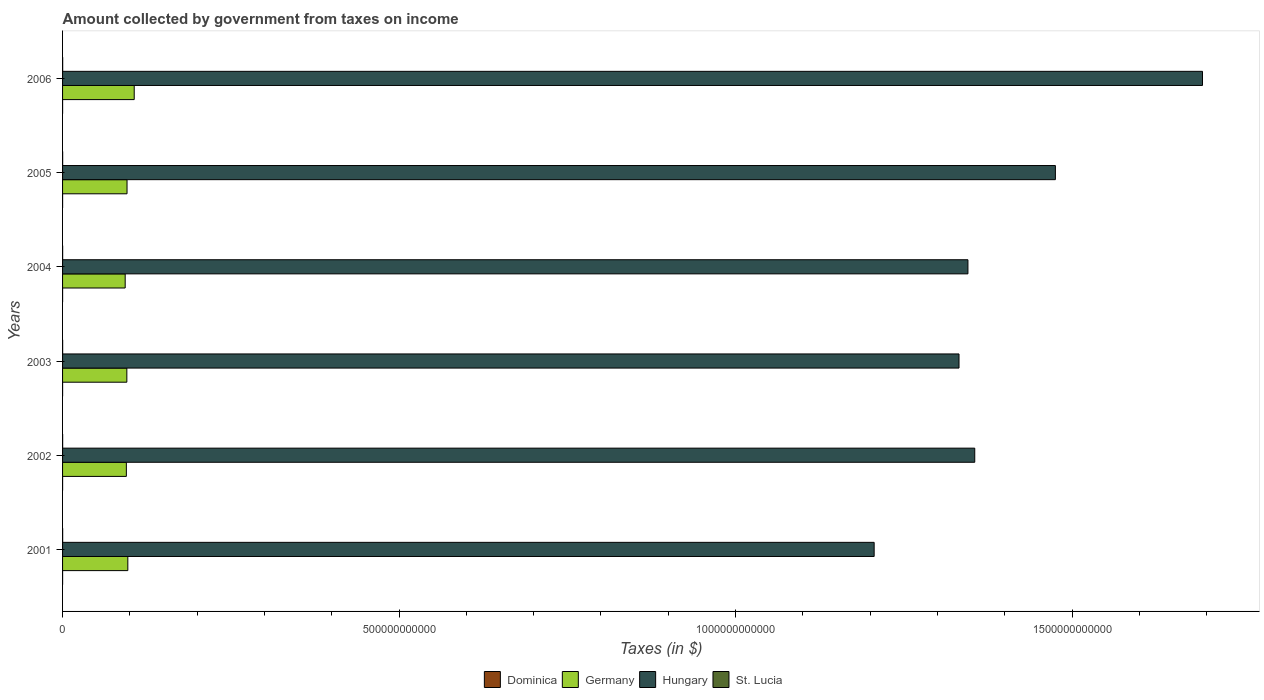How many different coloured bars are there?
Offer a very short reply. 4. How many groups of bars are there?
Offer a terse response. 6. Are the number of bars per tick equal to the number of legend labels?
Keep it short and to the point. Yes. What is the amount collected by government from taxes on income in Dominica in 2006?
Keep it short and to the point. 5.05e+07. Across all years, what is the maximum amount collected by government from taxes on income in Hungary?
Ensure brevity in your answer.  1.69e+12. Across all years, what is the minimum amount collected by government from taxes on income in Germany?
Offer a very short reply. 9.30e+1. In which year was the amount collected by government from taxes on income in Germany maximum?
Offer a terse response. 2006. What is the total amount collected by government from taxes on income in Dominica in the graph?
Keep it short and to the point. 2.72e+08. What is the difference between the amount collected by government from taxes on income in Germany in 2002 and that in 2004?
Provide a succinct answer. 1.74e+09. What is the difference between the amount collected by government from taxes on income in Germany in 2004 and the amount collected by government from taxes on income in St. Lucia in 2001?
Keep it short and to the point. 9.29e+1. What is the average amount collected by government from taxes on income in Dominica per year?
Your response must be concise. 4.53e+07. In the year 2005, what is the difference between the amount collected by government from taxes on income in Germany and amount collected by government from taxes on income in Hungary?
Offer a terse response. -1.38e+12. What is the ratio of the amount collected by government from taxes on income in Germany in 2005 to that in 2006?
Provide a succinct answer. 0.9. What is the difference between the highest and the second highest amount collected by government from taxes on income in Hungary?
Keep it short and to the point. 2.19e+11. What is the difference between the highest and the lowest amount collected by government from taxes on income in Hungary?
Your answer should be very brief. 4.88e+11. Is it the case that in every year, the sum of the amount collected by government from taxes on income in St. Lucia and amount collected by government from taxes on income in Germany is greater than the sum of amount collected by government from taxes on income in Dominica and amount collected by government from taxes on income in Hungary?
Keep it short and to the point. No. What does the 2nd bar from the top in 2004 represents?
Keep it short and to the point. Hungary. What does the 3rd bar from the bottom in 2003 represents?
Give a very brief answer. Hungary. How many bars are there?
Ensure brevity in your answer.  24. Are all the bars in the graph horizontal?
Your answer should be very brief. Yes. How many years are there in the graph?
Offer a terse response. 6. What is the difference between two consecutive major ticks on the X-axis?
Your answer should be very brief. 5.00e+11. Does the graph contain any zero values?
Provide a succinct answer. No. Where does the legend appear in the graph?
Your answer should be compact. Bottom center. How are the legend labels stacked?
Make the answer very short. Horizontal. What is the title of the graph?
Your response must be concise. Amount collected by government from taxes on income. What is the label or title of the X-axis?
Offer a terse response. Taxes (in $). What is the Taxes (in $) of Dominica in 2001?
Make the answer very short. 4.45e+07. What is the Taxes (in $) in Germany in 2001?
Your answer should be compact. 9.70e+1. What is the Taxes (in $) in Hungary in 2001?
Keep it short and to the point. 1.21e+12. What is the Taxes (in $) in St. Lucia in 2001?
Offer a terse response. 1.34e+08. What is the Taxes (in $) of Dominica in 2002?
Your response must be concise. 4.16e+07. What is the Taxes (in $) in Germany in 2002?
Your answer should be compact. 9.48e+1. What is the Taxes (in $) in Hungary in 2002?
Keep it short and to the point. 1.36e+12. What is the Taxes (in $) in St. Lucia in 2002?
Your answer should be very brief. 1.08e+08. What is the Taxes (in $) of Dominica in 2003?
Your answer should be compact. 4.52e+07. What is the Taxes (in $) in Germany in 2003?
Provide a short and direct response. 9.55e+1. What is the Taxes (in $) of Hungary in 2003?
Offer a terse response. 1.33e+12. What is the Taxes (in $) in St. Lucia in 2003?
Your response must be concise. 1.10e+08. What is the Taxes (in $) in Dominica in 2004?
Your answer should be very brief. 3.92e+07. What is the Taxes (in $) in Germany in 2004?
Offer a terse response. 9.30e+1. What is the Taxes (in $) of Hungary in 2004?
Offer a very short reply. 1.35e+12. What is the Taxes (in $) of St. Lucia in 2004?
Provide a succinct answer. 1.16e+08. What is the Taxes (in $) of Dominica in 2005?
Give a very brief answer. 5.07e+07. What is the Taxes (in $) of Germany in 2005?
Keep it short and to the point. 9.58e+1. What is the Taxes (in $) in Hungary in 2005?
Provide a succinct answer. 1.48e+12. What is the Taxes (in $) in St. Lucia in 2005?
Provide a succinct answer. 1.40e+08. What is the Taxes (in $) of Dominica in 2006?
Your answer should be compact. 5.05e+07. What is the Taxes (in $) of Germany in 2006?
Ensure brevity in your answer.  1.06e+11. What is the Taxes (in $) of Hungary in 2006?
Provide a succinct answer. 1.69e+12. What is the Taxes (in $) of St. Lucia in 2006?
Give a very brief answer. 1.48e+08. Across all years, what is the maximum Taxes (in $) of Dominica?
Ensure brevity in your answer.  5.07e+07. Across all years, what is the maximum Taxes (in $) in Germany?
Your response must be concise. 1.06e+11. Across all years, what is the maximum Taxes (in $) of Hungary?
Your answer should be very brief. 1.69e+12. Across all years, what is the maximum Taxes (in $) in St. Lucia?
Keep it short and to the point. 1.48e+08. Across all years, what is the minimum Taxes (in $) in Dominica?
Make the answer very short. 3.92e+07. Across all years, what is the minimum Taxes (in $) of Germany?
Keep it short and to the point. 9.30e+1. Across all years, what is the minimum Taxes (in $) of Hungary?
Keep it short and to the point. 1.21e+12. Across all years, what is the minimum Taxes (in $) of St. Lucia?
Provide a succinct answer. 1.08e+08. What is the total Taxes (in $) of Dominica in the graph?
Provide a short and direct response. 2.72e+08. What is the total Taxes (in $) in Germany in the graph?
Offer a terse response. 5.83e+11. What is the total Taxes (in $) of Hungary in the graph?
Provide a succinct answer. 8.41e+12. What is the total Taxes (in $) of St. Lucia in the graph?
Make the answer very short. 7.55e+08. What is the difference between the Taxes (in $) in Dominica in 2001 and that in 2002?
Provide a short and direct response. 2.90e+06. What is the difference between the Taxes (in $) of Germany in 2001 and that in 2002?
Keep it short and to the point. 2.18e+09. What is the difference between the Taxes (in $) of Hungary in 2001 and that in 2002?
Provide a short and direct response. -1.49e+11. What is the difference between the Taxes (in $) of St. Lucia in 2001 and that in 2002?
Provide a succinct answer. 2.61e+07. What is the difference between the Taxes (in $) in Dominica in 2001 and that in 2003?
Keep it short and to the point. -7.00e+05. What is the difference between the Taxes (in $) of Germany in 2001 and that in 2003?
Make the answer very short. 1.47e+09. What is the difference between the Taxes (in $) of Hungary in 2001 and that in 2003?
Offer a very short reply. -1.26e+11. What is the difference between the Taxes (in $) in St. Lucia in 2001 and that in 2003?
Offer a terse response. 2.40e+07. What is the difference between the Taxes (in $) in Dominica in 2001 and that in 2004?
Your answer should be very brief. 5.30e+06. What is the difference between the Taxes (in $) of Germany in 2001 and that in 2004?
Provide a succinct answer. 3.92e+09. What is the difference between the Taxes (in $) of Hungary in 2001 and that in 2004?
Your answer should be very brief. -1.39e+11. What is the difference between the Taxes (in $) of St. Lucia in 2001 and that in 2004?
Provide a succinct answer. 1.73e+07. What is the difference between the Taxes (in $) of Dominica in 2001 and that in 2005?
Give a very brief answer. -6.20e+06. What is the difference between the Taxes (in $) in Germany in 2001 and that in 2005?
Your answer should be very brief. 1.17e+09. What is the difference between the Taxes (in $) in Hungary in 2001 and that in 2005?
Provide a short and direct response. -2.69e+11. What is the difference between the Taxes (in $) in St. Lucia in 2001 and that in 2005?
Your response must be concise. -5.90e+06. What is the difference between the Taxes (in $) of Dominica in 2001 and that in 2006?
Give a very brief answer. -6.00e+06. What is the difference between the Taxes (in $) in Germany in 2001 and that in 2006?
Your response must be concise. -9.50e+09. What is the difference between the Taxes (in $) in Hungary in 2001 and that in 2006?
Give a very brief answer. -4.88e+11. What is the difference between the Taxes (in $) of St. Lucia in 2001 and that in 2006?
Your answer should be very brief. -1.47e+07. What is the difference between the Taxes (in $) of Dominica in 2002 and that in 2003?
Keep it short and to the point. -3.60e+06. What is the difference between the Taxes (in $) of Germany in 2002 and that in 2003?
Keep it short and to the point. -7.10e+08. What is the difference between the Taxes (in $) of Hungary in 2002 and that in 2003?
Provide a succinct answer. 2.34e+1. What is the difference between the Taxes (in $) in St. Lucia in 2002 and that in 2003?
Make the answer very short. -2.10e+06. What is the difference between the Taxes (in $) of Dominica in 2002 and that in 2004?
Offer a very short reply. 2.40e+06. What is the difference between the Taxes (in $) of Germany in 2002 and that in 2004?
Keep it short and to the point. 1.74e+09. What is the difference between the Taxes (in $) of Hungary in 2002 and that in 2004?
Offer a very short reply. 1.01e+1. What is the difference between the Taxes (in $) in St. Lucia in 2002 and that in 2004?
Offer a very short reply. -8.80e+06. What is the difference between the Taxes (in $) of Dominica in 2002 and that in 2005?
Ensure brevity in your answer.  -9.10e+06. What is the difference between the Taxes (in $) in Germany in 2002 and that in 2005?
Your answer should be very brief. -1.01e+09. What is the difference between the Taxes (in $) in Hungary in 2002 and that in 2005?
Keep it short and to the point. -1.20e+11. What is the difference between the Taxes (in $) in St. Lucia in 2002 and that in 2005?
Offer a very short reply. -3.20e+07. What is the difference between the Taxes (in $) in Dominica in 2002 and that in 2006?
Provide a succinct answer. -8.90e+06. What is the difference between the Taxes (in $) in Germany in 2002 and that in 2006?
Offer a very short reply. -1.17e+1. What is the difference between the Taxes (in $) of Hungary in 2002 and that in 2006?
Ensure brevity in your answer.  -3.38e+11. What is the difference between the Taxes (in $) of St. Lucia in 2002 and that in 2006?
Make the answer very short. -4.08e+07. What is the difference between the Taxes (in $) of Dominica in 2003 and that in 2004?
Give a very brief answer. 6.00e+06. What is the difference between the Taxes (in $) in Germany in 2003 and that in 2004?
Your answer should be very brief. 2.45e+09. What is the difference between the Taxes (in $) of Hungary in 2003 and that in 2004?
Provide a succinct answer. -1.33e+1. What is the difference between the Taxes (in $) in St. Lucia in 2003 and that in 2004?
Provide a short and direct response. -6.70e+06. What is the difference between the Taxes (in $) in Dominica in 2003 and that in 2005?
Provide a succinct answer. -5.50e+06. What is the difference between the Taxes (in $) in Germany in 2003 and that in 2005?
Your answer should be compact. -3.00e+08. What is the difference between the Taxes (in $) in Hungary in 2003 and that in 2005?
Offer a terse response. -1.43e+11. What is the difference between the Taxes (in $) of St. Lucia in 2003 and that in 2005?
Your response must be concise. -2.99e+07. What is the difference between the Taxes (in $) of Dominica in 2003 and that in 2006?
Give a very brief answer. -5.30e+06. What is the difference between the Taxes (in $) in Germany in 2003 and that in 2006?
Give a very brief answer. -1.10e+1. What is the difference between the Taxes (in $) of Hungary in 2003 and that in 2006?
Offer a terse response. -3.62e+11. What is the difference between the Taxes (in $) of St. Lucia in 2003 and that in 2006?
Offer a very short reply. -3.87e+07. What is the difference between the Taxes (in $) of Dominica in 2004 and that in 2005?
Offer a terse response. -1.15e+07. What is the difference between the Taxes (in $) in Germany in 2004 and that in 2005?
Make the answer very short. -2.75e+09. What is the difference between the Taxes (in $) of Hungary in 2004 and that in 2005?
Keep it short and to the point. -1.30e+11. What is the difference between the Taxes (in $) in St. Lucia in 2004 and that in 2005?
Your answer should be compact. -2.32e+07. What is the difference between the Taxes (in $) of Dominica in 2004 and that in 2006?
Offer a very short reply. -1.13e+07. What is the difference between the Taxes (in $) of Germany in 2004 and that in 2006?
Offer a terse response. -1.34e+1. What is the difference between the Taxes (in $) of Hungary in 2004 and that in 2006?
Provide a succinct answer. -3.49e+11. What is the difference between the Taxes (in $) in St. Lucia in 2004 and that in 2006?
Give a very brief answer. -3.20e+07. What is the difference between the Taxes (in $) of Dominica in 2005 and that in 2006?
Keep it short and to the point. 2.00e+05. What is the difference between the Taxes (in $) of Germany in 2005 and that in 2006?
Make the answer very short. -1.07e+1. What is the difference between the Taxes (in $) of Hungary in 2005 and that in 2006?
Keep it short and to the point. -2.19e+11. What is the difference between the Taxes (in $) in St. Lucia in 2005 and that in 2006?
Offer a very short reply. -8.80e+06. What is the difference between the Taxes (in $) in Dominica in 2001 and the Taxes (in $) in Germany in 2002?
Provide a succinct answer. -9.47e+1. What is the difference between the Taxes (in $) of Dominica in 2001 and the Taxes (in $) of Hungary in 2002?
Your answer should be very brief. -1.36e+12. What is the difference between the Taxes (in $) in Dominica in 2001 and the Taxes (in $) in St. Lucia in 2002?
Offer a very short reply. -6.31e+07. What is the difference between the Taxes (in $) in Germany in 2001 and the Taxes (in $) in Hungary in 2002?
Make the answer very short. -1.26e+12. What is the difference between the Taxes (in $) in Germany in 2001 and the Taxes (in $) in St. Lucia in 2002?
Your response must be concise. 9.69e+1. What is the difference between the Taxes (in $) of Hungary in 2001 and the Taxes (in $) of St. Lucia in 2002?
Your response must be concise. 1.21e+12. What is the difference between the Taxes (in $) in Dominica in 2001 and the Taxes (in $) in Germany in 2003?
Your answer should be very brief. -9.55e+1. What is the difference between the Taxes (in $) of Dominica in 2001 and the Taxes (in $) of Hungary in 2003?
Your answer should be compact. -1.33e+12. What is the difference between the Taxes (in $) in Dominica in 2001 and the Taxes (in $) in St. Lucia in 2003?
Your answer should be very brief. -6.52e+07. What is the difference between the Taxes (in $) of Germany in 2001 and the Taxes (in $) of Hungary in 2003?
Ensure brevity in your answer.  -1.24e+12. What is the difference between the Taxes (in $) in Germany in 2001 and the Taxes (in $) in St. Lucia in 2003?
Your answer should be compact. 9.69e+1. What is the difference between the Taxes (in $) of Hungary in 2001 and the Taxes (in $) of St. Lucia in 2003?
Your answer should be very brief. 1.21e+12. What is the difference between the Taxes (in $) of Dominica in 2001 and the Taxes (in $) of Germany in 2004?
Provide a short and direct response. -9.30e+1. What is the difference between the Taxes (in $) in Dominica in 2001 and the Taxes (in $) in Hungary in 2004?
Offer a terse response. -1.35e+12. What is the difference between the Taxes (in $) in Dominica in 2001 and the Taxes (in $) in St. Lucia in 2004?
Provide a succinct answer. -7.19e+07. What is the difference between the Taxes (in $) in Germany in 2001 and the Taxes (in $) in Hungary in 2004?
Provide a short and direct response. -1.25e+12. What is the difference between the Taxes (in $) of Germany in 2001 and the Taxes (in $) of St. Lucia in 2004?
Keep it short and to the point. 9.69e+1. What is the difference between the Taxes (in $) of Hungary in 2001 and the Taxes (in $) of St. Lucia in 2004?
Make the answer very short. 1.21e+12. What is the difference between the Taxes (in $) of Dominica in 2001 and the Taxes (in $) of Germany in 2005?
Make the answer very short. -9.58e+1. What is the difference between the Taxes (in $) of Dominica in 2001 and the Taxes (in $) of Hungary in 2005?
Keep it short and to the point. -1.48e+12. What is the difference between the Taxes (in $) in Dominica in 2001 and the Taxes (in $) in St. Lucia in 2005?
Ensure brevity in your answer.  -9.51e+07. What is the difference between the Taxes (in $) of Germany in 2001 and the Taxes (in $) of Hungary in 2005?
Provide a short and direct response. -1.38e+12. What is the difference between the Taxes (in $) in Germany in 2001 and the Taxes (in $) in St. Lucia in 2005?
Offer a very short reply. 9.68e+1. What is the difference between the Taxes (in $) in Hungary in 2001 and the Taxes (in $) in St. Lucia in 2005?
Offer a very short reply. 1.21e+12. What is the difference between the Taxes (in $) of Dominica in 2001 and the Taxes (in $) of Germany in 2006?
Ensure brevity in your answer.  -1.06e+11. What is the difference between the Taxes (in $) of Dominica in 2001 and the Taxes (in $) of Hungary in 2006?
Your answer should be compact. -1.69e+12. What is the difference between the Taxes (in $) in Dominica in 2001 and the Taxes (in $) in St. Lucia in 2006?
Provide a short and direct response. -1.04e+08. What is the difference between the Taxes (in $) in Germany in 2001 and the Taxes (in $) in Hungary in 2006?
Make the answer very short. -1.60e+12. What is the difference between the Taxes (in $) of Germany in 2001 and the Taxes (in $) of St. Lucia in 2006?
Make the answer very short. 9.68e+1. What is the difference between the Taxes (in $) in Hungary in 2001 and the Taxes (in $) in St. Lucia in 2006?
Ensure brevity in your answer.  1.21e+12. What is the difference between the Taxes (in $) of Dominica in 2002 and the Taxes (in $) of Germany in 2003?
Your answer should be very brief. -9.55e+1. What is the difference between the Taxes (in $) in Dominica in 2002 and the Taxes (in $) in Hungary in 2003?
Your answer should be compact. -1.33e+12. What is the difference between the Taxes (in $) in Dominica in 2002 and the Taxes (in $) in St. Lucia in 2003?
Give a very brief answer. -6.81e+07. What is the difference between the Taxes (in $) in Germany in 2002 and the Taxes (in $) in Hungary in 2003?
Offer a terse response. -1.24e+12. What is the difference between the Taxes (in $) in Germany in 2002 and the Taxes (in $) in St. Lucia in 2003?
Ensure brevity in your answer.  9.47e+1. What is the difference between the Taxes (in $) of Hungary in 2002 and the Taxes (in $) of St. Lucia in 2003?
Ensure brevity in your answer.  1.36e+12. What is the difference between the Taxes (in $) of Dominica in 2002 and the Taxes (in $) of Germany in 2004?
Give a very brief answer. -9.30e+1. What is the difference between the Taxes (in $) of Dominica in 2002 and the Taxes (in $) of Hungary in 2004?
Offer a terse response. -1.35e+12. What is the difference between the Taxes (in $) in Dominica in 2002 and the Taxes (in $) in St. Lucia in 2004?
Offer a very short reply. -7.48e+07. What is the difference between the Taxes (in $) of Germany in 2002 and the Taxes (in $) of Hungary in 2004?
Ensure brevity in your answer.  -1.25e+12. What is the difference between the Taxes (in $) in Germany in 2002 and the Taxes (in $) in St. Lucia in 2004?
Offer a very short reply. 9.47e+1. What is the difference between the Taxes (in $) in Hungary in 2002 and the Taxes (in $) in St. Lucia in 2004?
Your response must be concise. 1.36e+12. What is the difference between the Taxes (in $) in Dominica in 2002 and the Taxes (in $) in Germany in 2005?
Provide a short and direct response. -9.58e+1. What is the difference between the Taxes (in $) of Dominica in 2002 and the Taxes (in $) of Hungary in 2005?
Offer a terse response. -1.48e+12. What is the difference between the Taxes (in $) in Dominica in 2002 and the Taxes (in $) in St. Lucia in 2005?
Your answer should be very brief. -9.80e+07. What is the difference between the Taxes (in $) in Germany in 2002 and the Taxes (in $) in Hungary in 2005?
Your answer should be compact. -1.38e+12. What is the difference between the Taxes (in $) in Germany in 2002 and the Taxes (in $) in St. Lucia in 2005?
Make the answer very short. 9.47e+1. What is the difference between the Taxes (in $) in Hungary in 2002 and the Taxes (in $) in St. Lucia in 2005?
Provide a short and direct response. 1.36e+12. What is the difference between the Taxes (in $) in Dominica in 2002 and the Taxes (in $) in Germany in 2006?
Offer a very short reply. -1.06e+11. What is the difference between the Taxes (in $) of Dominica in 2002 and the Taxes (in $) of Hungary in 2006?
Give a very brief answer. -1.69e+12. What is the difference between the Taxes (in $) of Dominica in 2002 and the Taxes (in $) of St. Lucia in 2006?
Provide a succinct answer. -1.07e+08. What is the difference between the Taxes (in $) in Germany in 2002 and the Taxes (in $) in Hungary in 2006?
Your answer should be compact. -1.60e+12. What is the difference between the Taxes (in $) of Germany in 2002 and the Taxes (in $) of St. Lucia in 2006?
Your response must be concise. 9.46e+1. What is the difference between the Taxes (in $) in Hungary in 2002 and the Taxes (in $) in St. Lucia in 2006?
Offer a very short reply. 1.36e+12. What is the difference between the Taxes (in $) of Dominica in 2003 and the Taxes (in $) of Germany in 2004?
Keep it short and to the point. -9.30e+1. What is the difference between the Taxes (in $) in Dominica in 2003 and the Taxes (in $) in Hungary in 2004?
Ensure brevity in your answer.  -1.35e+12. What is the difference between the Taxes (in $) in Dominica in 2003 and the Taxes (in $) in St. Lucia in 2004?
Your response must be concise. -7.12e+07. What is the difference between the Taxes (in $) of Germany in 2003 and the Taxes (in $) of Hungary in 2004?
Make the answer very short. -1.25e+12. What is the difference between the Taxes (in $) in Germany in 2003 and the Taxes (in $) in St. Lucia in 2004?
Your response must be concise. 9.54e+1. What is the difference between the Taxes (in $) in Hungary in 2003 and the Taxes (in $) in St. Lucia in 2004?
Ensure brevity in your answer.  1.33e+12. What is the difference between the Taxes (in $) of Dominica in 2003 and the Taxes (in $) of Germany in 2005?
Provide a succinct answer. -9.58e+1. What is the difference between the Taxes (in $) in Dominica in 2003 and the Taxes (in $) in Hungary in 2005?
Ensure brevity in your answer.  -1.48e+12. What is the difference between the Taxes (in $) of Dominica in 2003 and the Taxes (in $) of St. Lucia in 2005?
Give a very brief answer. -9.44e+07. What is the difference between the Taxes (in $) of Germany in 2003 and the Taxes (in $) of Hungary in 2005?
Your response must be concise. -1.38e+12. What is the difference between the Taxes (in $) of Germany in 2003 and the Taxes (in $) of St. Lucia in 2005?
Provide a short and direct response. 9.54e+1. What is the difference between the Taxes (in $) of Hungary in 2003 and the Taxes (in $) of St. Lucia in 2005?
Your response must be concise. 1.33e+12. What is the difference between the Taxes (in $) in Dominica in 2003 and the Taxes (in $) in Germany in 2006?
Keep it short and to the point. -1.06e+11. What is the difference between the Taxes (in $) in Dominica in 2003 and the Taxes (in $) in Hungary in 2006?
Your answer should be compact. -1.69e+12. What is the difference between the Taxes (in $) in Dominica in 2003 and the Taxes (in $) in St. Lucia in 2006?
Provide a succinct answer. -1.03e+08. What is the difference between the Taxes (in $) in Germany in 2003 and the Taxes (in $) in Hungary in 2006?
Offer a very short reply. -1.60e+12. What is the difference between the Taxes (in $) in Germany in 2003 and the Taxes (in $) in St. Lucia in 2006?
Ensure brevity in your answer.  9.54e+1. What is the difference between the Taxes (in $) in Hungary in 2003 and the Taxes (in $) in St. Lucia in 2006?
Provide a succinct answer. 1.33e+12. What is the difference between the Taxes (in $) of Dominica in 2004 and the Taxes (in $) of Germany in 2005?
Keep it short and to the point. -9.58e+1. What is the difference between the Taxes (in $) in Dominica in 2004 and the Taxes (in $) in Hungary in 2005?
Ensure brevity in your answer.  -1.48e+12. What is the difference between the Taxes (in $) in Dominica in 2004 and the Taxes (in $) in St. Lucia in 2005?
Make the answer very short. -1.00e+08. What is the difference between the Taxes (in $) of Germany in 2004 and the Taxes (in $) of Hungary in 2005?
Offer a terse response. -1.38e+12. What is the difference between the Taxes (in $) of Germany in 2004 and the Taxes (in $) of St. Lucia in 2005?
Your answer should be very brief. 9.29e+1. What is the difference between the Taxes (in $) of Hungary in 2004 and the Taxes (in $) of St. Lucia in 2005?
Provide a short and direct response. 1.35e+12. What is the difference between the Taxes (in $) of Dominica in 2004 and the Taxes (in $) of Germany in 2006?
Give a very brief answer. -1.06e+11. What is the difference between the Taxes (in $) of Dominica in 2004 and the Taxes (in $) of Hungary in 2006?
Offer a very short reply. -1.69e+12. What is the difference between the Taxes (in $) in Dominica in 2004 and the Taxes (in $) in St. Lucia in 2006?
Provide a succinct answer. -1.09e+08. What is the difference between the Taxes (in $) in Germany in 2004 and the Taxes (in $) in Hungary in 2006?
Provide a short and direct response. -1.60e+12. What is the difference between the Taxes (in $) of Germany in 2004 and the Taxes (in $) of St. Lucia in 2006?
Offer a very short reply. 9.29e+1. What is the difference between the Taxes (in $) of Hungary in 2004 and the Taxes (in $) of St. Lucia in 2006?
Offer a very short reply. 1.35e+12. What is the difference between the Taxes (in $) of Dominica in 2005 and the Taxes (in $) of Germany in 2006?
Provide a short and direct response. -1.06e+11. What is the difference between the Taxes (in $) of Dominica in 2005 and the Taxes (in $) of Hungary in 2006?
Your answer should be very brief. -1.69e+12. What is the difference between the Taxes (in $) in Dominica in 2005 and the Taxes (in $) in St. Lucia in 2006?
Make the answer very short. -9.77e+07. What is the difference between the Taxes (in $) in Germany in 2005 and the Taxes (in $) in Hungary in 2006?
Offer a terse response. -1.60e+12. What is the difference between the Taxes (in $) of Germany in 2005 and the Taxes (in $) of St. Lucia in 2006?
Your answer should be very brief. 9.57e+1. What is the difference between the Taxes (in $) of Hungary in 2005 and the Taxes (in $) of St. Lucia in 2006?
Provide a short and direct response. 1.48e+12. What is the average Taxes (in $) in Dominica per year?
Provide a short and direct response. 4.53e+07. What is the average Taxes (in $) of Germany per year?
Give a very brief answer. 9.71e+1. What is the average Taxes (in $) in Hungary per year?
Provide a succinct answer. 1.40e+12. What is the average Taxes (in $) of St. Lucia per year?
Keep it short and to the point. 1.26e+08. In the year 2001, what is the difference between the Taxes (in $) in Dominica and Taxes (in $) in Germany?
Your response must be concise. -9.69e+1. In the year 2001, what is the difference between the Taxes (in $) of Dominica and Taxes (in $) of Hungary?
Offer a terse response. -1.21e+12. In the year 2001, what is the difference between the Taxes (in $) in Dominica and Taxes (in $) in St. Lucia?
Offer a terse response. -8.92e+07. In the year 2001, what is the difference between the Taxes (in $) of Germany and Taxes (in $) of Hungary?
Provide a short and direct response. -1.11e+12. In the year 2001, what is the difference between the Taxes (in $) in Germany and Taxes (in $) in St. Lucia?
Make the answer very short. 9.68e+1. In the year 2001, what is the difference between the Taxes (in $) in Hungary and Taxes (in $) in St. Lucia?
Provide a short and direct response. 1.21e+12. In the year 2002, what is the difference between the Taxes (in $) in Dominica and Taxes (in $) in Germany?
Provide a short and direct response. -9.47e+1. In the year 2002, what is the difference between the Taxes (in $) in Dominica and Taxes (in $) in Hungary?
Ensure brevity in your answer.  -1.36e+12. In the year 2002, what is the difference between the Taxes (in $) in Dominica and Taxes (in $) in St. Lucia?
Give a very brief answer. -6.60e+07. In the year 2002, what is the difference between the Taxes (in $) in Germany and Taxes (in $) in Hungary?
Provide a short and direct response. -1.26e+12. In the year 2002, what is the difference between the Taxes (in $) of Germany and Taxes (in $) of St. Lucia?
Your answer should be very brief. 9.47e+1. In the year 2002, what is the difference between the Taxes (in $) in Hungary and Taxes (in $) in St. Lucia?
Give a very brief answer. 1.36e+12. In the year 2003, what is the difference between the Taxes (in $) of Dominica and Taxes (in $) of Germany?
Your response must be concise. -9.55e+1. In the year 2003, what is the difference between the Taxes (in $) of Dominica and Taxes (in $) of Hungary?
Give a very brief answer. -1.33e+12. In the year 2003, what is the difference between the Taxes (in $) of Dominica and Taxes (in $) of St. Lucia?
Ensure brevity in your answer.  -6.45e+07. In the year 2003, what is the difference between the Taxes (in $) in Germany and Taxes (in $) in Hungary?
Provide a short and direct response. -1.24e+12. In the year 2003, what is the difference between the Taxes (in $) of Germany and Taxes (in $) of St. Lucia?
Offer a very short reply. 9.54e+1. In the year 2003, what is the difference between the Taxes (in $) of Hungary and Taxes (in $) of St. Lucia?
Provide a short and direct response. 1.33e+12. In the year 2004, what is the difference between the Taxes (in $) of Dominica and Taxes (in $) of Germany?
Keep it short and to the point. -9.30e+1. In the year 2004, what is the difference between the Taxes (in $) in Dominica and Taxes (in $) in Hungary?
Provide a short and direct response. -1.35e+12. In the year 2004, what is the difference between the Taxes (in $) of Dominica and Taxes (in $) of St. Lucia?
Provide a short and direct response. -7.72e+07. In the year 2004, what is the difference between the Taxes (in $) of Germany and Taxes (in $) of Hungary?
Keep it short and to the point. -1.25e+12. In the year 2004, what is the difference between the Taxes (in $) of Germany and Taxes (in $) of St. Lucia?
Offer a very short reply. 9.29e+1. In the year 2004, what is the difference between the Taxes (in $) in Hungary and Taxes (in $) in St. Lucia?
Provide a short and direct response. 1.35e+12. In the year 2005, what is the difference between the Taxes (in $) of Dominica and Taxes (in $) of Germany?
Ensure brevity in your answer.  -9.57e+1. In the year 2005, what is the difference between the Taxes (in $) in Dominica and Taxes (in $) in Hungary?
Offer a terse response. -1.48e+12. In the year 2005, what is the difference between the Taxes (in $) in Dominica and Taxes (in $) in St. Lucia?
Offer a very short reply. -8.89e+07. In the year 2005, what is the difference between the Taxes (in $) in Germany and Taxes (in $) in Hungary?
Ensure brevity in your answer.  -1.38e+12. In the year 2005, what is the difference between the Taxes (in $) of Germany and Taxes (in $) of St. Lucia?
Ensure brevity in your answer.  9.57e+1. In the year 2005, what is the difference between the Taxes (in $) of Hungary and Taxes (in $) of St. Lucia?
Provide a succinct answer. 1.48e+12. In the year 2006, what is the difference between the Taxes (in $) in Dominica and Taxes (in $) in Germany?
Your answer should be very brief. -1.06e+11. In the year 2006, what is the difference between the Taxes (in $) of Dominica and Taxes (in $) of Hungary?
Give a very brief answer. -1.69e+12. In the year 2006, what is the difference between the Taxes (in $) in Dominica and Taxes (in $) in St. Lucia?
Your answer should be very brief. -9.79e+07. In the year 2006, what is the difference between the Taxes (in $) in Germany and Taxes (in $) in Hungary?
Provide a succinct answer. -1.59e+12. In the year 2006, what is the difference between the Taxes (in $) of Germany and Taxes (in $) of St. Lucia?
Your answer should be very brief. 1.06e+11. In the year 2006, what is the difference between the Taxes (in $) of Hungary and Taxes (in $) of St. Lucia?
Give a very brief answer. 1.69e+12. What is the ratio of the Taxes (in $) of Dominica in 2001 to that in 2002?
Provide a short and direct response. 1.07. What is the ratio of the Taxes (in $) in Hungary in 2001 to that in 2002?
Your answer should be compact. 0.89. What is the ratio of the Taxes (in $) in St. Lucia in 2001 to that in 2002?
Your answer should be very brief. 1.24. What is the ratio of the Taxes (in $) of Dominica in 2001 to that in 2003?
Keep it short and to the point. 0.98. What is the ratio of the Taxes (in $) of Germany in 2001 to that in 2003?
Provide a succinct answer. 1.02. What is the ratio of the Taxes (in $) of Hungary in 2001 to that in 2003?
Provide a succinct answer. 0.91. What is the ratio of the Taxes (in $) in St. Lucia in 2001 to that in 2003?
Ensure brevity in your answer.  1.22. What is the ratio of the Taxes (in $) of Dominica in 2001 to that in 2004?
Your response must be concise. 1.14. What is the ratio of the Taxes (in $) of Germany in 2001 to that in 2004?
Your response must be concise. 1.04. What is the ratio of the Taxes (in $) in Hungary in 2001 to that in 2004?
Keep it short and to the point. 0.9. What is the ratio of the Taxes (in $) in St. Lucia in 2001 to that in 2004?
Offer a very short reply. 1.15. What is the ratio of the Taxes (in $) of Dominica in 2001 to that in 2005?
Offer a very short reply. 0.88. What is the ratio of the Taxes (in $) of Germany in 2001 to that in 2005?
Your answer should be very brief. 1.01. What is the ratio of the Taxes (in $) in Hungary in 2001 to that in 2005?
Give a very brief answer. 0.82. What is the ratio of the Taxes (in $) of St. Lucia in 2001 to that in 2005?
Give a very brief answer. 0.96. What is the ratio of the Taxes (in $) of Dominica in 2001 to that in 2006?
Your answer should be compact. 0.88. What is the ratio of the Taxes (in $) of Germany in 2001 to that in 2006?
Ensure brevity in your answer.  0.91. What is the ratio of the Taxes (in $) in Hungary in 2001 to that in 2006?
Make the answer very short. 0.71. What is the ratio of the Taxes (in $) in St. Lucia in 2001 to that in 2006?
Offer a terse response. 0.9. What is the ratio of the Taxes (in $) of Dominica in 2002 to that in 2003?
Your response must be concise. 0.92. What is the ratio of the Taxes (in $) of Germany in 2002 to that in 2003?
Your answer should be very brief. 0.99. What is the ratio of the Taxes (in $) of Hungary in 2002 to that in 2003?
Provide a short and direct response. 1.02. What is the ratio of the Taxes (in $) of St. Lucia in 2002 to that in 2003?
Offer a terse response. 0.98. What is the ratio of the Taxes (in $) of Dominica in 2002 to that in 2004?
Provide a succinct answer. 1.06. What is the ratio of the Taxes (in $) in Germany in 2002 to that in 2004?
Your answer should be compact. 1.02. What is the ratio of the Taxes (in $) in Hungary in 2002 to that in 2004?
Your response must be concise. 1.01. What is the ratio of the Taxes (in $) in St. Lucia in 2002 to that in 2004?
Make the answer very short. 0.92. What is the ratio of the Taxes (in $) of Dominica in 2002 to that in 2005?
Give a very brief answer. 0.82. What is the ratio of the Taxes (in $) of Hungary in 2002 to that in 2005?
Provide a succinct answer. 0.92. What is the ratio of the Taxes (in $) of St. Lucia in 2002 to that in 2005?
Your response must be concise. 0.77. What is the ratio of the Taxes (in $) in Dominica in 2002 to that in 2006?
Your answer should be compact. 0.82. What is the ratio of the Taxes (in $) in Germany in 2002 to that in 2006?
Make the answer very short. 0.89. What is the ratio of the Taxes (in $) in Hungary in 2002 to that in 2006?
Your answer should be very brief. 0.8. What is the ratio of the Taxes (in $) of St. Lucia in 2002 to that in 2006?
Provide a short and direct response. 0.73. What is the ratio of the Taxes (in $) of Dominica in 2003 to that in 2004?
Your response must be concise. 1.15. What is the ratio of the Taxes (in $) in Germany in 2003 to that in 2004?
Offer a terse response. 1.03. What is the ratio of the Taxes (in $) in St. Lucia in 2003 to that in 2004?
Provide a succinct answer. 0.94. What is the ratio of the Taxes (in $) of Dominica in 2003 to that in 2005?
Provide a succinct answer. 0.89. What is the ratio of the Taxes (in $) of Germany in 2003 to that in 2005?
Provide a succinct answer. 1. What is the ratio of the Taxes (in $) in Hungary in 2003 to that in 2005?
Provide a succinct answer. 0.9. What is the ratio of the Taxes (in $) of St. Lucia in 2003 to that in 2005?
Provide a succinct answer. 0.79. What is the ratio of the Taxes (in $) in Dominica in 2003 to that in 2006?
Provide a short and direct response. 0.9. What is the ratio of the Taxes (in $) in Germany in 2003 to that in 2006?
Give a very brief answer. 0.9. What is the ratio of the Taxes (in $) in Hungary in 2003 to that in 2006?
Your answer should be compact. 0.79. What is the ratio of the Taxes (in $) of St. Lucia in 2003 to that in 2006?
Give a very brief answer. 0.74. What is the ratio of the Taxes (in $) in Dominica in 2004 to that in 2005?
Make the answer very short. 0.77. What is the ratio of the Taxes (in $) in Germany in 2004 to that in 2005?
Keep it short and to the point. 0.97. What is the ratio of the Taxes (in $) of Hungary in 2004 to that in 2005?
Your response must be concise. 0.91. What is the ratio of the Taxes (in $) in St. Lucia in 2004 to that in 2005?
Give a very brief answer. 0.83. What is the ratio of the Taxes (in $) of Dominica in 2004 to that in 2006?
Your answer should be very brief. 0.78. What is the ratio of the Taxes (in $) of Germany in 2004 to that in 2006?
Ensure brevity in your answer.  0.87. What is the ratio of the Taxes (in $) of Hungary in 2004 to that in 2006?
Make the answer very short. 0.79. What is the ratio of the Taxes (in $) in St. Lucia in 2004 to that in 2006?
Offer a very short reply. 0.78. What is the ratio of the Taxes (in $) in Germany in 2005 to that in 2006?
Keep it short and to the point. 0.9. What is the ratio of the Taxes (in $) of Hungary in 2005 to that in 2006?
Ensure brevity in your answer.  0.87. What is the ratio of the Taxes (in $) of St. Lucia in 2005 to that in 2006?
Your response must be concise. 0.94. What is the difference between the highest and the second highest Taxes (in $) in Germany?
Keep it short and to the point. 9.50e+09. What is the difference between the highest and the second highest Taxes (in $) of Hungary?
Provide a succinct answer. 2.19e+11. What is the difference between the highest and the second highest Taxes (in $) in St. Lucia?
Ensure brevity in your answer.  8.80e+06. What is the difference between the highest and the lowest Taxes (in $) of Dominica?
Offer a very short reply. 1.15e+07. What is the difference between the highest and the lowest Taxes (in $) in Germany?
Ensure brevity in your answer.  1.34e+1. What is the difference between the highest and the lowest Taxes (in $) of Hungary?
Your answer should be very brief. 4.88e+11. What is the difference between the highest and the lowest Taxes (in $) in St. Lucia?
Your response must be concise. 4.08e+07. 